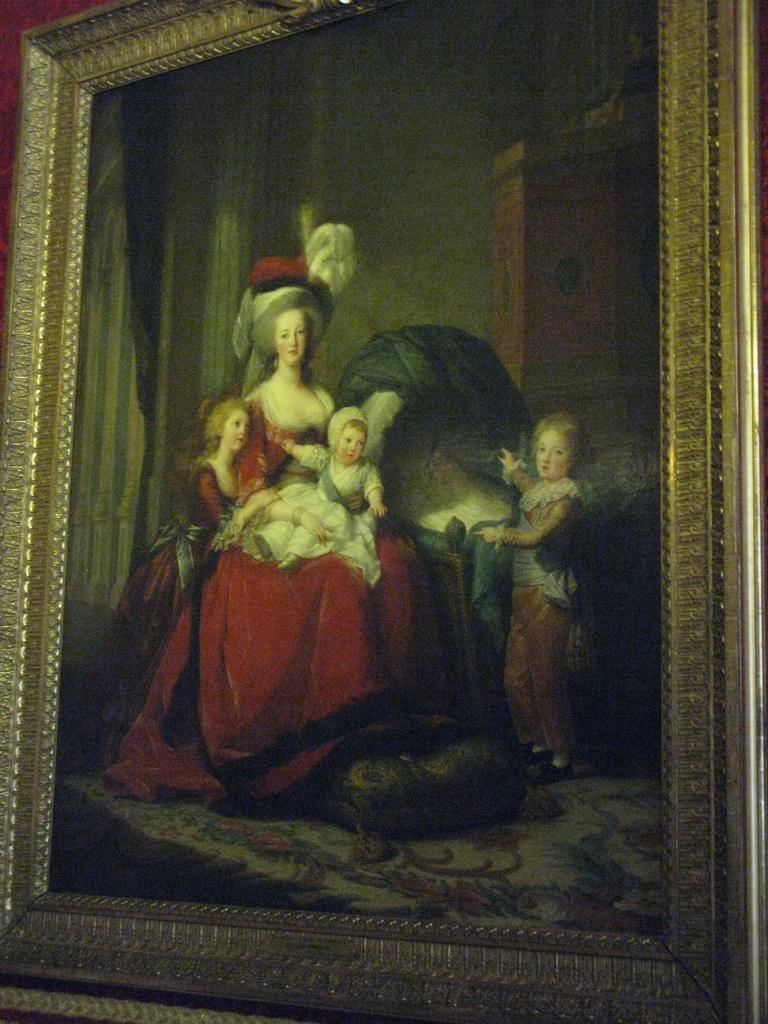In one or two sentences, can you explain what this image depicts? In this image we can see a photo frame of a painting, in that we can see three kids and a lady, lady is wearing red color dress, and she is sitting on the chair. 